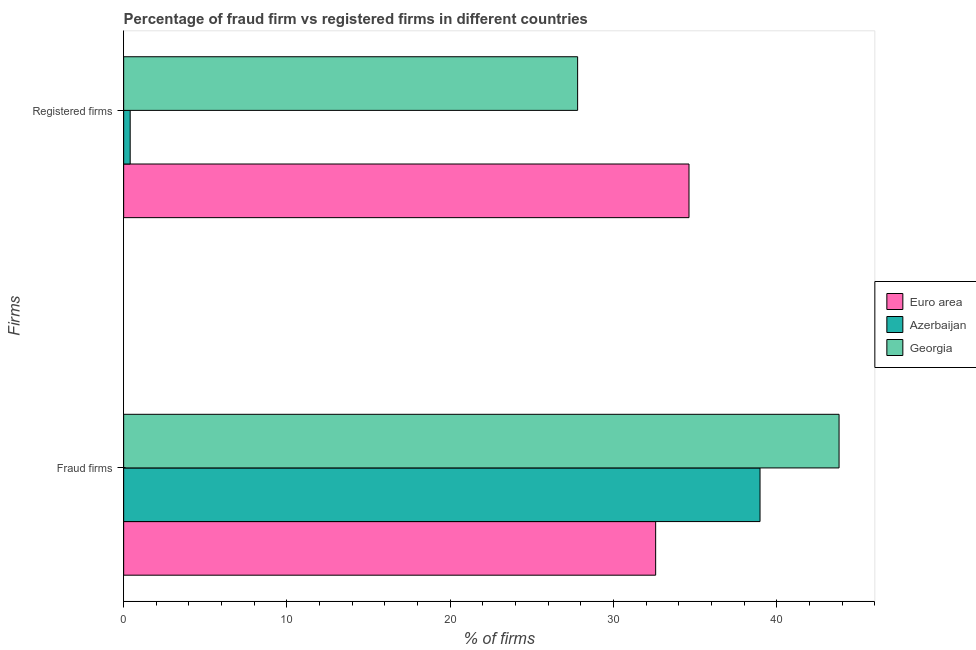How many different coloured bars are there?
Your response must be concise. 3. How many bars are there on the 2nd tick from the top?
Keep it short and to the point. 3. What is the label of the 2nd group of bars from the top?
Make the answer very short. Fraud firms. Across all countries, what is the maximum percentage of fraud firms?
Keep it short and to the point. 43.81. Across all countries, what is the minimum percentage of fraud firms?
Your response must be concise. 32.58. In which country was the percentage of fraud firms maximum?
Offer a very short reply. Georgia. In which country was the percentage of registered firms minimum?
Make the answer very short. Azerbaijan. What is the total percentage of registered firms in the graph?
Make the answer very short. 62.82. What is the difference between the percentage of registered firms in Azerbaijan and that in Georgia?
Your answer should be very brief. -27.4. What is the difference between the percentage of registered firms in Georgia and the percentage of fraud firms in Azerbaijan?
Provide a short and direct response. -11.17. What is the average percentage of fraud firms per country?
Ensure brevity in your answer.  38.45. What is the difference between the percentage of registered firms and percentage of fraud firms in Azerbaijan?
Give a very brief answer. -38.57. What is the ratio of the percentage of registered firms in Euro area to that in Azerbaijan?
Your answer should be very brief. 86.55. Is the percentage of fraud firms in Georgia less than that in Azerbaijan?
Your response must be concise. No. In how many countries, is the percentage of fraud firms greater than the average percentage of fraud firms taken over all countries?
Make the answer very short. 2. What does the 1st bar from the top in Fraud firms represents?
Your response must be concise. Georgia. What does the 1st bar from the bottom in Fraud firms represents?
Make the answer very short. Euro area. What is the difference between two consecutive major ticks on the X-axis?
Ensure brevity in your answer.  10. Does the graph contain any zero values?
Ensure brevity in your answer.  No. Does the graph contain grids?
Your answer should be very brief. No. Where does the legend appear in the graph?
Give a very brief answer. Center right. What is the title of the graph?
Keep it short and to the point. Percentage of fraud firm vs registered firms in different countries. Does "Cyprus" appear as one of the legend labels in the graph?
Offer a very short reply. No. What is the label or title of the X-axis?
Offer a very short reply. % of firms. What is the label or title of the Y-axis?
Offer a very short reply. Firms. What is the % of firms of Euro area in Fraud firms?
Your answer should be compact. 32.58. What is the % of firms of Azerbaijan in Fraud firms?
Offer a terse response. 38.97. What is the % of firms in Georgia in Fraud firms?
Provide a short and direct response. 43.81. What is the % of firms of Euro area in Registered firms?
Give a very brief answer. 34.62. What is the % of firms of Georgia in Registered firms?
Your answer should be very brief. 27.8. Across all Firms, what is the maximum % of firms in Euro area?
Keep it short and to the point. 34.62. Across all Firms, what is the maximum % of firms in Azerbaijan?
Ensure brevity in your answer.  38.97. Across all Firms, what is the maximum % of firms of Georgia?
Offer a terse response. 43.81. Across all Firms, what is the minimum % of firms of Euro area?
Your answer should be very brief. 32.58. Across all Firms, what is the minimum % of firms in Azerbaijan?
Ensure brevity in your answer.  0.4. Across all Firms, what is the minimum % of firms in Georgia?
Provide a short and direct response. 27.8. What is the total % of firms of Euro area in the graph?
Make the answer very short. 67.2. What is the total % of firms of Azerbaijan in the graph?
Give a very brief answer. 39.37. What is the total % of firms in Georgia in the graph?
Provide a succinct answer. 71.61. What is the difference between the % of firms of Euro area in Fraud firms and that in Registered firms?
Your answer should be compact. -2.04. What is the difference between the % of firms of Azerbaijan in Fraud firms and that in Registered firms?
Make the answer very short. 38.57. What is the difference between the % of firms in Georgia in Fraud firms and that in Registered firms?
Make the answer very short. 16.01. What is the difference between the % of firms of Euro area in Fraud firms and the % of firms of Azerbaijan in Registered firms?
Your answer should be compact. 32.18. What is the difference between the % of firms in Euro area in Fraud firms and the % of firms in Georgia in Registered firms?
Your answer should be compact. 4.78. What is the difference between the % of firms in Azerbaijan in Fraud firms and the % of firms in Georgia in Registered firms?
Offer a terse response. 11.17. What is the average % of firms of Euro area per Firms?
Provide a short and direct response. 33.6. What is the average % of firms in Azerbaijan per Firms?
Give a very brief answer. 19.68. What is the average % of firms in Georgia per Firms?
Offer a very short reply. 35.8. What is the difference between the % of firms of Euro area and % of firms of Azerbaijan in Fraud firms?
Your answer should be very brief. -6.39. What is the difference between the % of firms of Euro area and % of firms of Georgia in Fraud firms?
Offer a terse response. -11.23. What is the difference between the % of firms in Azerbaijan and % of firms in Georgia in Fraud firms?
Make the answer very short. -4.84. What is the difference between the % of firms of Euro area and % of firms of Azerbaijan in Registered firms?
Give a very brief answer. 34.22. What is the difference between the % of firms in Euro area and % of firms in Georgia in Registered firms?
Your answer should be very brief. 6.82. What is the difference between the % of firms of Azerbaijan and % of firms of Georgia in Registered firms?
Ensure brevity in your answer.  -27.4. What is the ratio of the % of firms in Euro area in Fraud firms to that in Registered firms?
Provide a succinct answer. 0.94. What is the ratio of the % of firms of Azerbaijan in Fraud firms to that in Registered firms?
Offer a very short reply. 97.42. What is the ratio of the % of firms of Georgia in Fraud firms to that in Registered firms?
Provide a succinct answer. 1.58. What is the difference between the highest and the second highest % of firms in Euro area?
Give a very brief answer. 2.04. What is the difference between the highest and the second highest % of firms in Azerbaijan?
Your answer should be very brief. 38.57. What is the difference between the highest and the second highest % of firms in Georgia?
Offer a terse response. 16.01. What is the difference between the highest and the lowest % of firms of Euro area?
Your answer should be very brief. 2.04. What is the difference between the highest and the lowest % of firms in Azerbaijan?
Your answer should be compact. 38.57. What is the difference between the highest and the lowest % of firms in Georgia?
Your answer should be very brief. 16.01. 